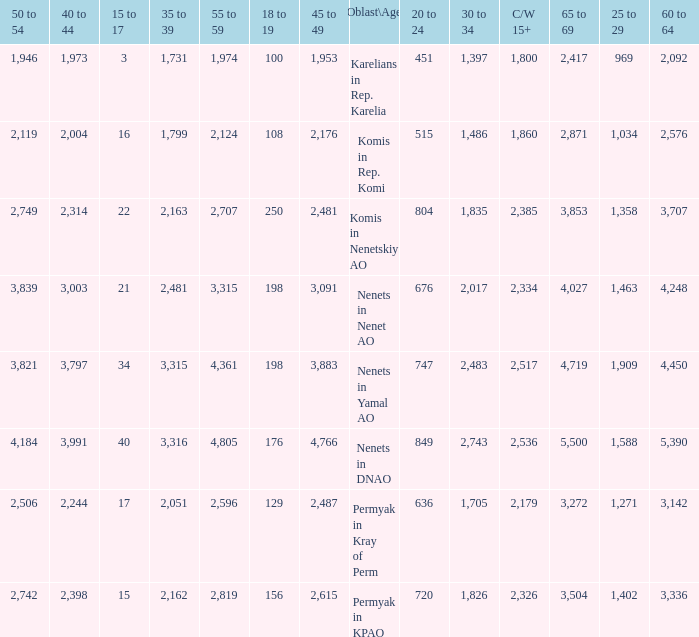With a 20 to 24 less than 676, and a 15 to 17 greater than 16, and a 60 to 64 less than 3,142, what is the average 45 to 49? None. 